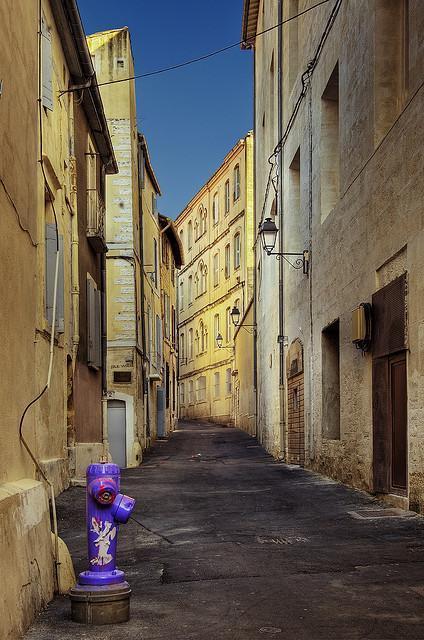How many people are outside of the train?
Give a very brief answer. 0. 